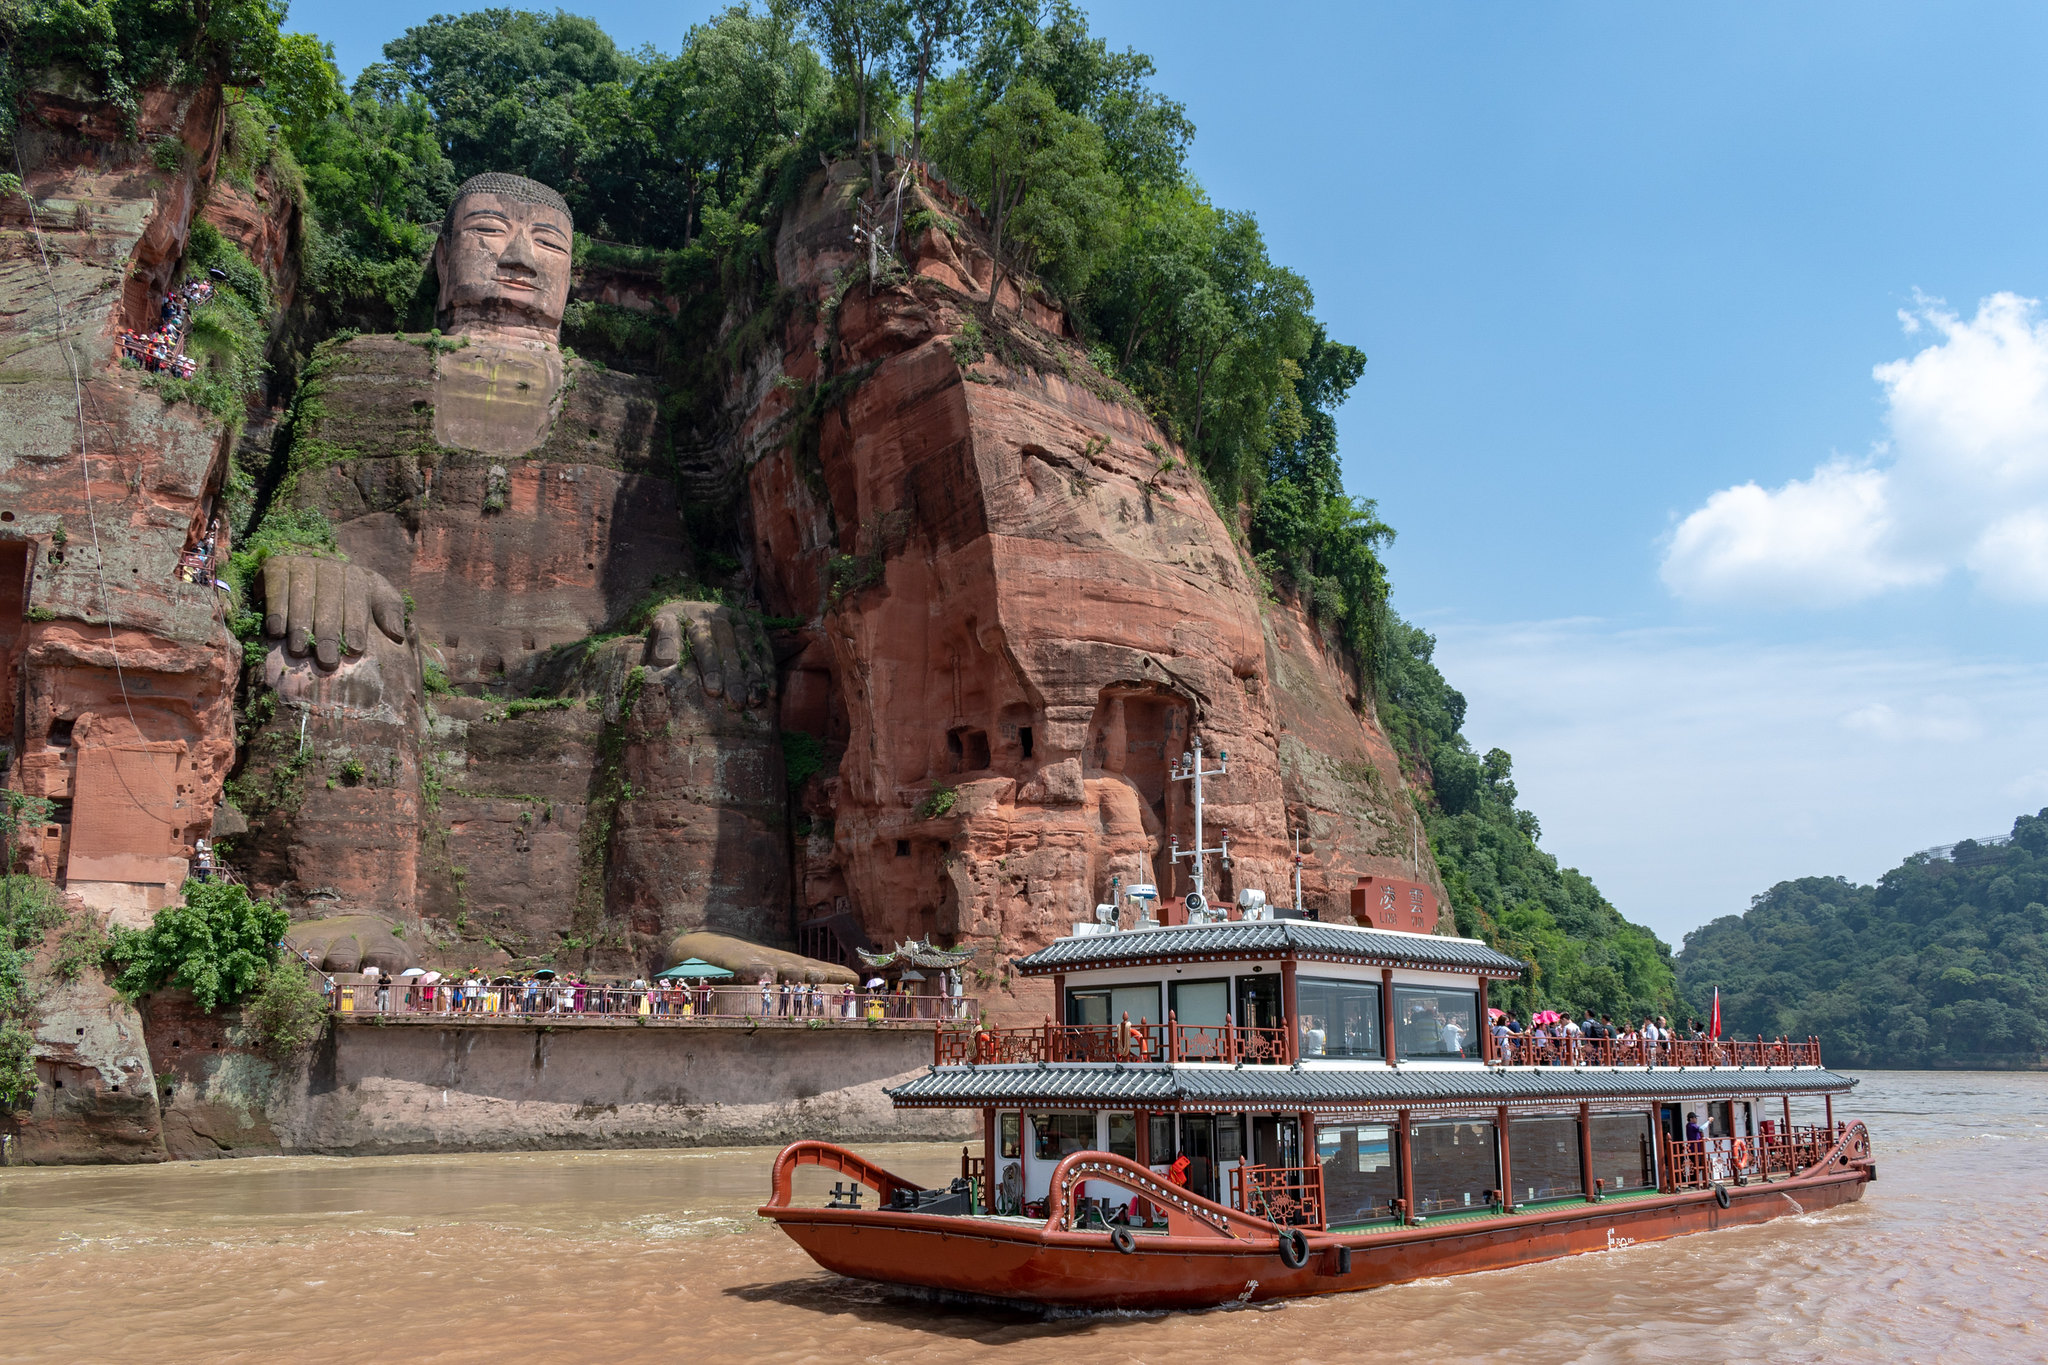If you were to experience being in this boat, what would the journey be like? Imagining the journey from the perspective of a boat passenger, you would first be struck by the grandeur of the Leshan Giant Buddha as it slowly comes into view. The sense of anticipation builds as the boat glides along the river, surrounded by the natural beauty of the lush green trees and steep cliffs. The sound of the water lapping against the boat and the gentle hum of the engine add to the atmosphere. As you get closer, the details of the colossal Buddha become more apparent, from the intricately carved features to the moss-covered crevices. The journey offers a serene and contemplative experience, juxtaposing the magnificence of human craftsmanship with the tranquility of nature. What might be a creative story about the origins of the statue? Legend has it that the Leshan Giant Buddha was not carved by human hands alone, but with the guidance of celestial beings. One night, a humble monk named Haitong received a vision where he was visited by the spirit of a wise old sage. The sage revealed that the turbulent waters could only be tamed by a guardian of immense spiritual power. Guided by this divine vision, Haitong dedicated his life to the creation of this guardian – the Buddha. As he worked tirelessly, it is said that heavenly creatures descended nightly to assist in the carving, ensuring the statue was imbued with divine energy. When the statue was finally completed, the river’s fury was calmed, and prosperity returned to the villagers. To this day, visitors feel a sense of peace and awe, as if touched by the celestial presence that helped forge the great Buddha. 